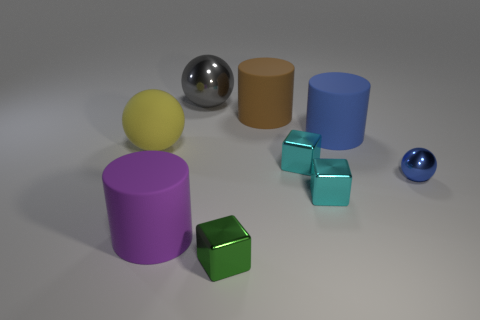Subtract all large spheres. How many spheres are left? 1 Subtract all yellow balls. How many balls are left? 2 Subtract 2 cylinders. How many cylinders are left? 1 Add 1 small cubes. How many objects exist? 10 Subtract all blue cylinders. How many cyan blocks are left? 2 Subtract all balls. How many objects are left? 6 Add 5 balls. How many balls are left? 8 Add 4 large metallic cylinders. How many large metallic cylinders exist? 4 Subtract 0 yellow cylinders. How many objects are left? 9 Subtract all yellow cylinders. Subtract all green spheres. How many cylinders are left? 3 